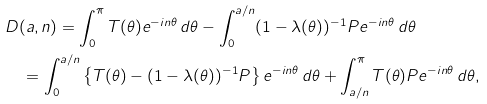<formula> <loc_0><loc_0><loc_500><loc_500>& D ( a , n ) = \int _ { 0 } ^ { \pi } T ( \theta ) e ^ { - i n \theta } \, d \theta - \int _ { 0 } ^ { a / n } ( 1 - \lambda ( \theta ) ) ^ { - 1 } P e ^ { - i n \theta } \, d \theta \\ & \quad = \int _ { 0 } ^ { a / n } \left \{ T ( \theta ) - ( 1 - \lambda ( \theta ) ) ^ { - 1 } P \right \} e ^ { - i n \theta } \, d \theta + \int _ { a / n } ^ { \pi } T ( \theta ) P e ^ { - i n \theta } \, d \theta ,</formula> 